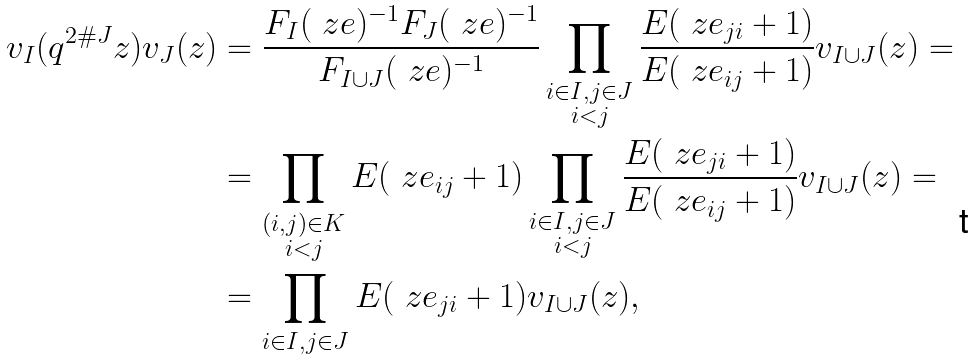<formula> <loc_0><loc_0><loc_500><loc_500>v _ { I } ( q ^ { 2 \# J } z ) v _ { J } ( z ) & = \frac { F _ { I } ( \ z e ) ^ { - 1 } F _ { J } ( \ z e ) ^ { - 1 } } { F _ { I \cup J } ( \ z e ) ^ { - 1 } } \prod _ { \substack { i \in I , j \in J \\ i < j } } \frac { E ( \ z e _ { j i } + 1 ) } { E ( \ z e _ { i j } + 1 ) } v _ { I \cup J } ( z ) = \\ & = \prod _ { \substack { ( i , j ) \in K \\ i < j } } E ( \ z e _ { i j } + 1 ) \prod _ { \substack { i \in I , j \in J \\ i < j } } \frac { E ( \ z e _ { j i } + 1 ) } { E ( \ z e _ { i j } + 1 ) } v _ { I \cup J } ( z ) = \\ & = \prod _ { i \in I , j \in J } E ( \ z e _ { j i } + 1 ) v _ { I \cup J } ( z ) ,</formula> 